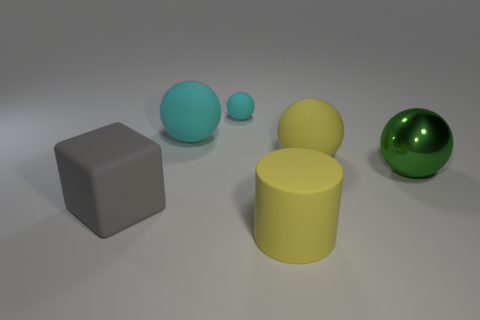Subtract all blue balls. Subtract all yellow blocks. How many balls are left? 4 Add 1 tiny brown matte cylinders. How many objects exist? 7 Subtract all cubes. How many objects are left? 5 Add 2 spheres. How many spheres are left? 6 Add 1 big yellow rubber balls. How many big yellow rubber balls exist? 2 Subtract 1 yellow cylinders. How many objects are left? 5 Subtract all metallic cylinders. Subtract all yellow matte cylinders. How many objects are left? 5 